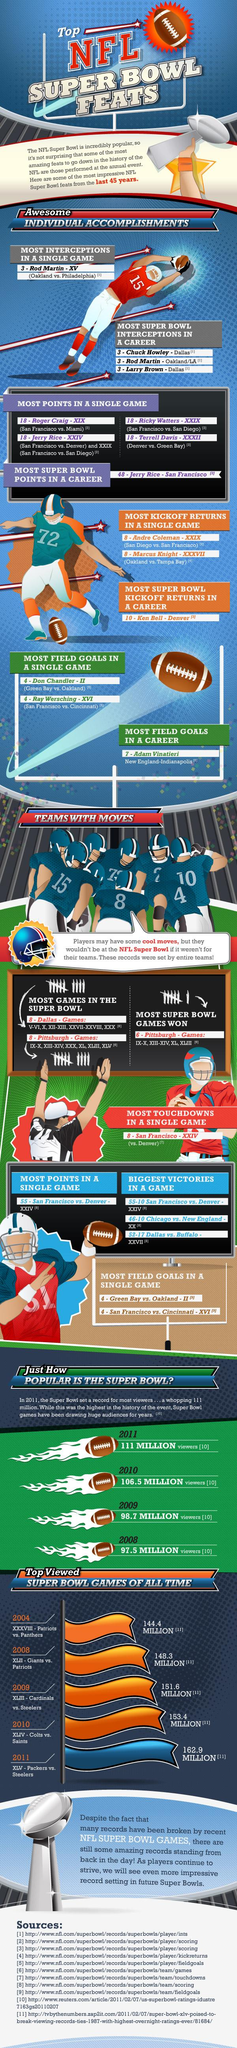Specify some key components in this picture. In the match between Denver and Green Bay, Terrell achieved the greatest number of points in a single game. As of my knowledge cutoff in 2021, two players from Dallas have earned recognition for the most Super Bowl interceptions. In a game between the San Francisco 49ers and the San Diego Chargers, Ricky Watters achieved the greatest number of points in a single game. I am pleased to announce that the second player from Dallas who received recognition for the most Super Bowl interceptions is none other than Larry Brown. The second-largest number of people watched the Super Bowl matches in the year 2010. 